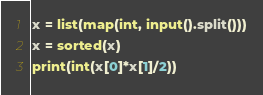Convert code to text. <code><loc_0><loc_0><loc_500><loc_500><_Python_>x = list(map(int, input().split()))
x = sorted(x)
print(int(x[0]*x[1]/2))
</code> 